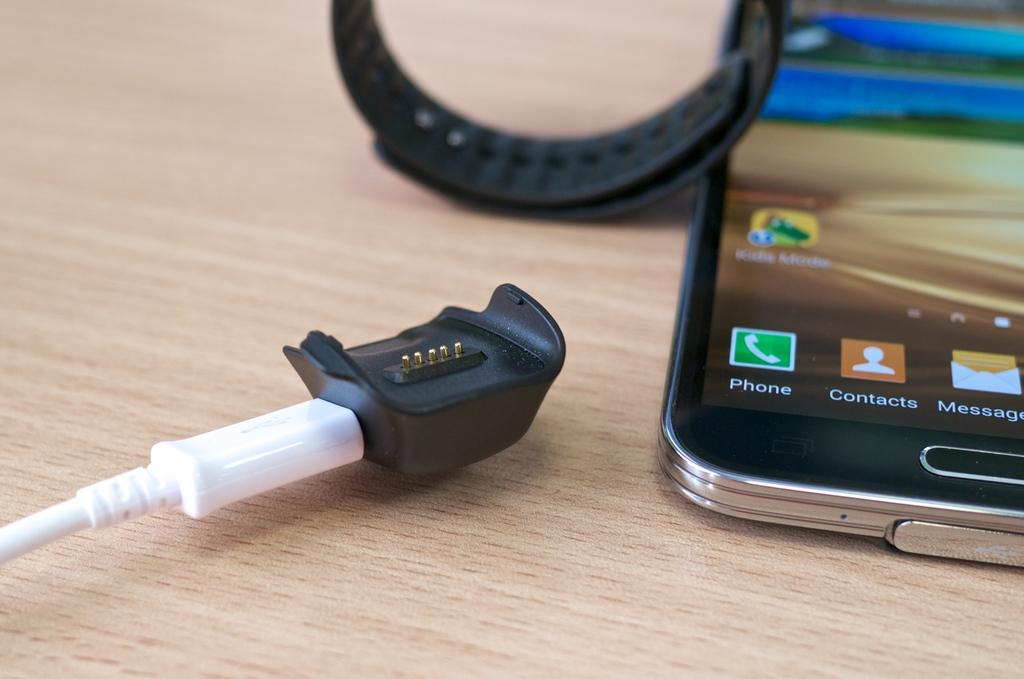<image>
Create a compact narrative representing the image presented. the icon phone that is on a cell phone 